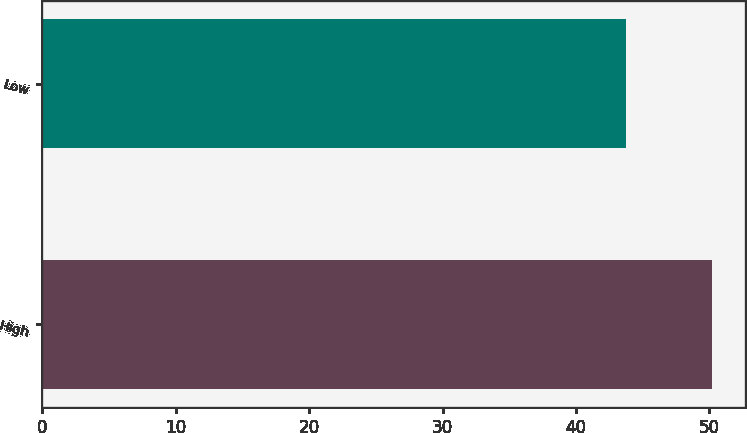Convert chart to OTSL. <chart><loc_0><loc_0><loc_500><loc_500><bar_chart><fcel>High<fcel>Low<nl><fcel>50.16<fcel>43.77<nl></chart> 